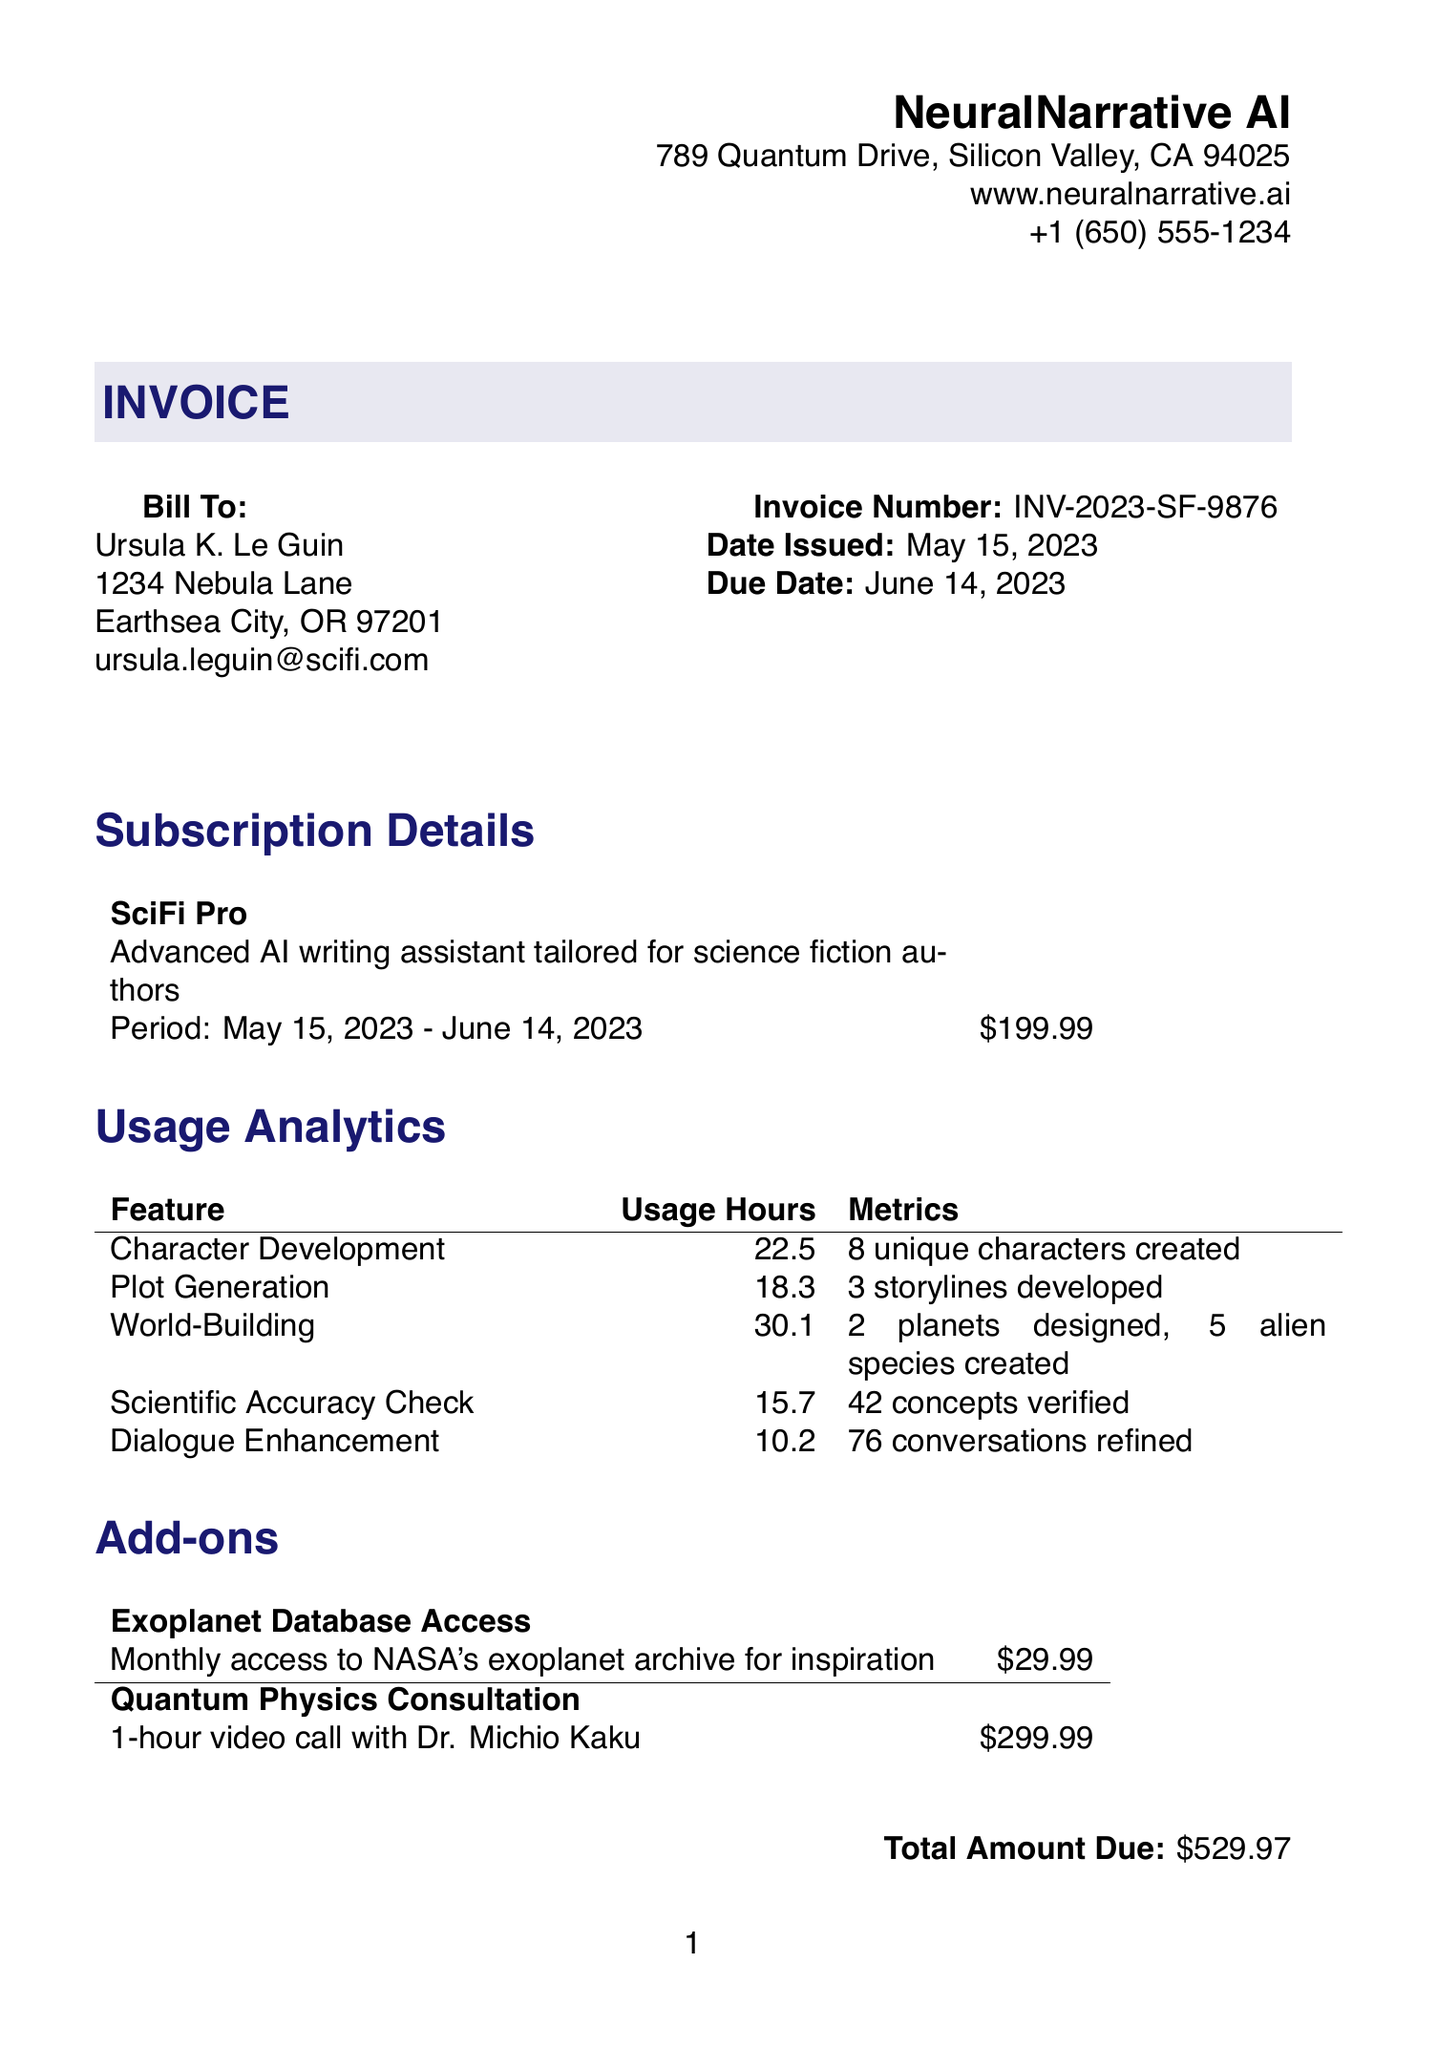What is the invoice number? The invoice number is a unique identifier for the transaction listed in the document.
Answer: INV-2023-SF-9876 What is the date issued? The date issued indicates when the invoice was generated, which is found in the document's header.
Answer: May 15, 2023 What is the total amount due? The total amount due reflects the total charges listed in the invoice, including any subscriptions and add-ons.
Answer: $529.97 Who is the customer? The customer information includes the name of the individual or company the invoice is addressed to.
Answer: Ursula K. Le Guin How many hours were spent on world-building? This question asks for the total usage hours specifically for the world-building feature listed in the analytics section.
Answer: 30.1 What payment methods are available? The payment methods are the different options available for paying the invoice as stated in the document.
Answer: Credit Card, PayPal, Bank Transfer What feature had the most usage hours? This question requires analyzing the usage hours across various features to find the one with the highest total.
Answer: World-Building What is included in the subscriptions description? The subscriptions description explains the nature of the subscription service provided, giving insight into its focus area.
Answer: Advanced AI writing assistant tailored for science fiction authors How long is the subscription period? The subscription period indicates the duration of the service covered by the invoice and can be found in the subscription details.
Answer: May 15, 2023 - June 14, 2023 